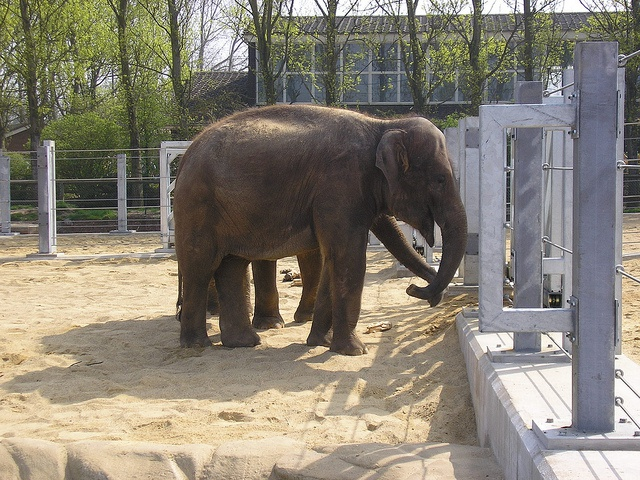Describe the objects in this image and their specific colors. I can see elephant in darkgreen, black, and gray tones, elephant in darkgreen, black, maroon, and gray tones, and elephant in darkgreen, black, maroon, and gray tones in this image. 